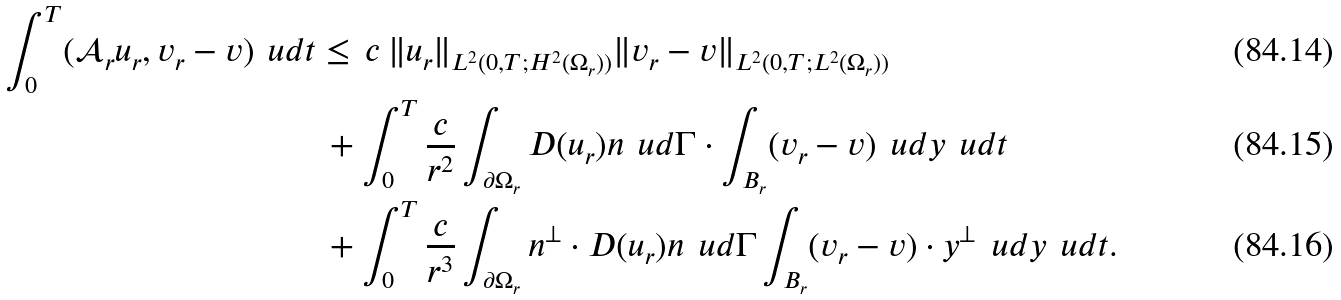Convert formula to latex. <formula><loc_0><loc_0><loc_500><loc_500>\int _ { 0 } ^ { T } ( \mathcal { A } _ { r } u _ { r } , v _ { r } - v ) \, \ u d t & \leq \, c \, \| u _ { r } \| _ { L ^ { 2 } ( 0 , T ; H ^ { 2 } ( \Omega _ { r } ) ) } \| v _ { r } - v \| _ { L ^ { 2 } ( 0 , T ; L ^ { 2 } ( \Omega _ { r } ) ) } \\ & \, + \int _ { 0 } ^ { T } \frac { c } { r ^ { 2 } } \int _ { \partial \Omega _ { r } } D ( u _ { r } ) { n } \, \ u d \Gamma \cdot \int _ { B _ { r } } ( v _ { r } - v ) \, \ u d y \, \ u d t \\ & \, + \int _ { 0 } ^ { T } \frac { c } { r ^ { 3 } } \int _ { \partial \Omega _ { r } } { n } ^ { \bot } \cdot D ( u _ { r } ) { n } \, \ u d \Gamma \int _ { B _ { r } } ( v _ { r } - v ) \cdot y ^ { \bot } \, \ u d y \, \ u d t .</formula> 